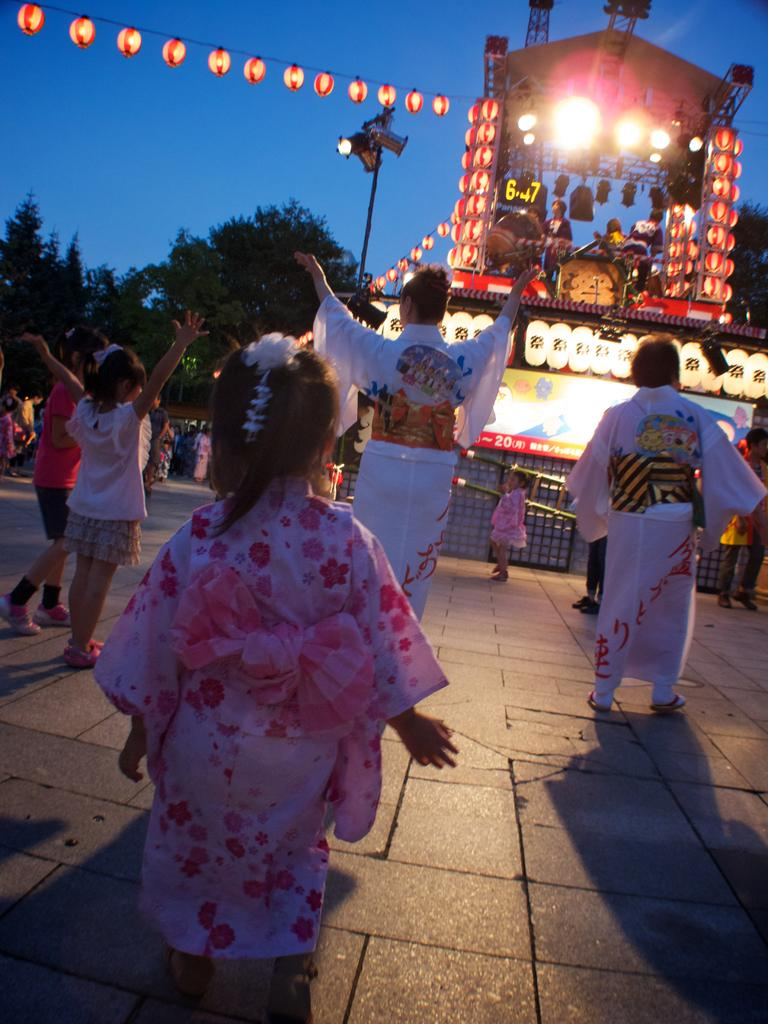What is happening in the image? There are people standing in the image. What is in front of the people? There is an object in front of the people. Are there any people on the object? Yes, there are persons standing on the object. What can be seen in the background of the image? There are trees in the background of the image. What type of juice is being served from the horn in the image? There is no horn or juice present in the image. 